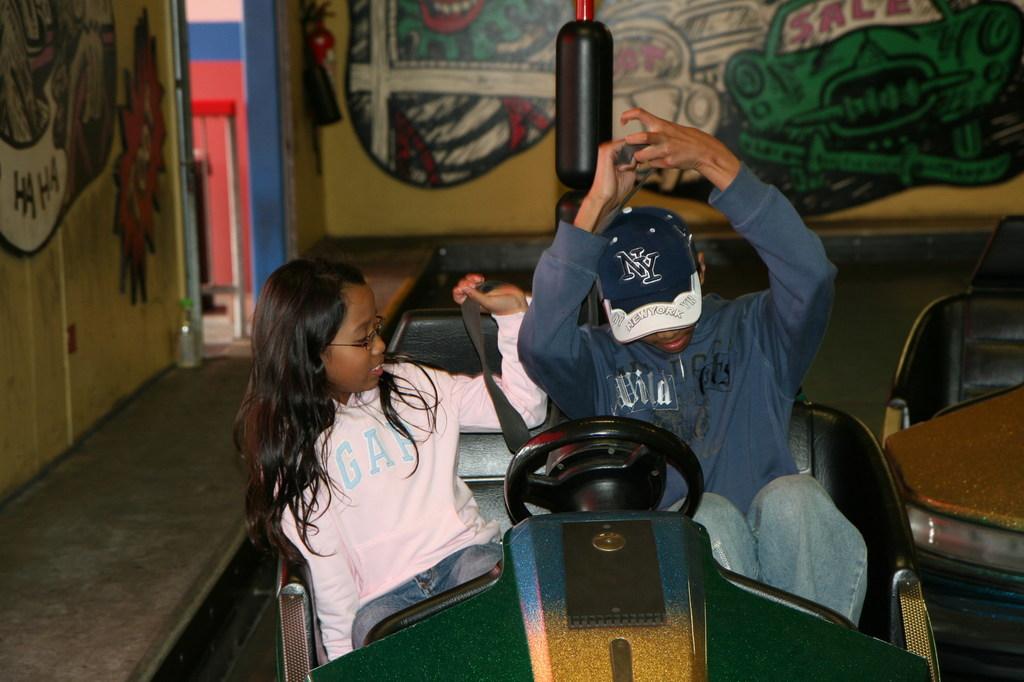What team is on the hat?
Offer a very short reply. New york. 